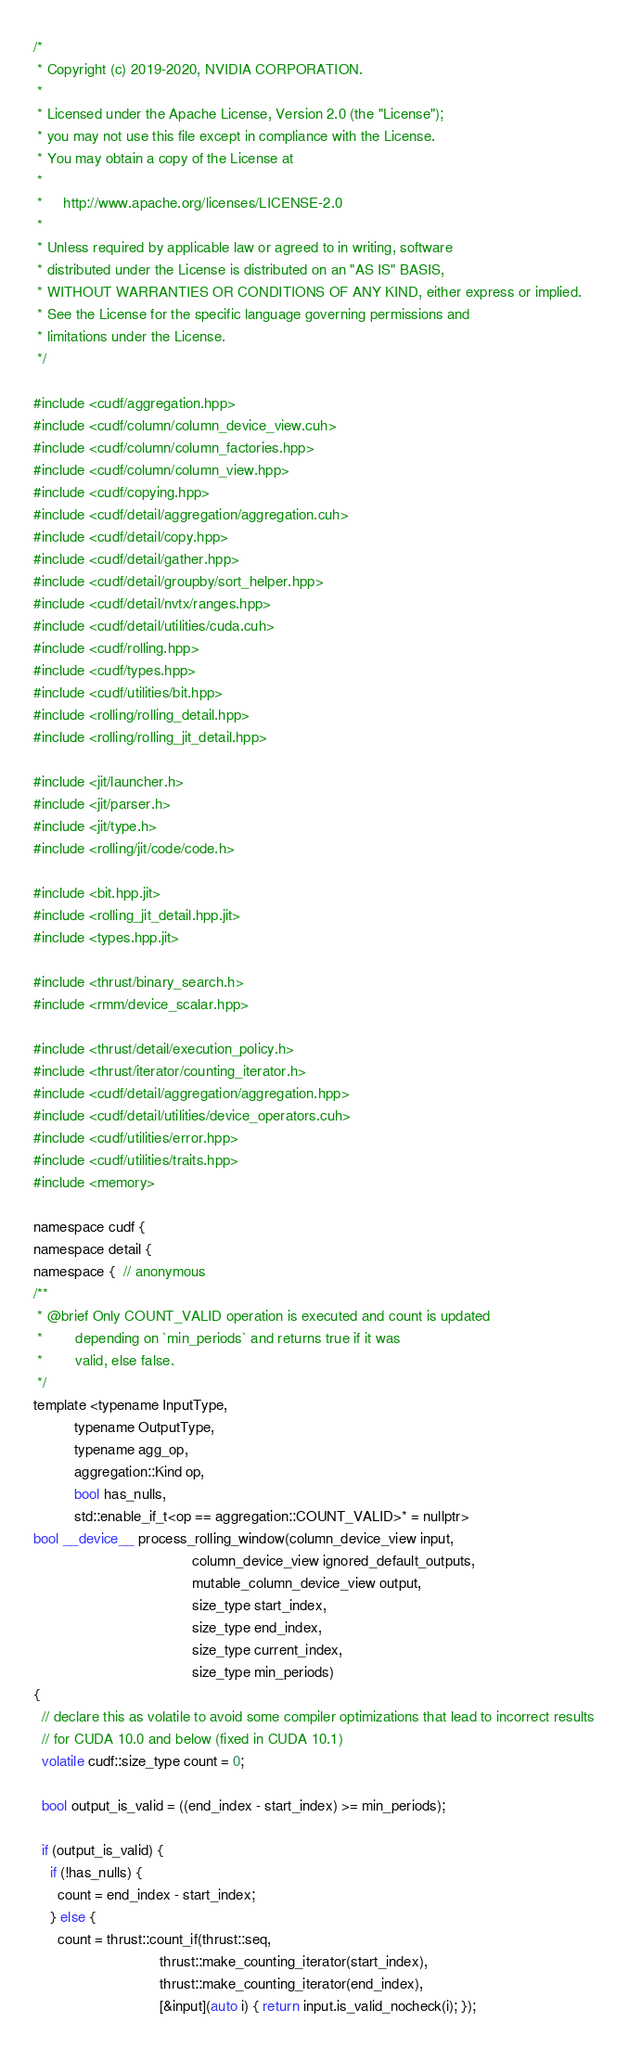<code> <loc_0><loc_0><loc_500><loc_500><_Cuda_>/*
 * Copyright (c) 2019-2020, NVIDIA CORPORATION.
 *
 * Licensed under the Apache License, Version 2.0 (the "License");
 * you may not use this file except in compliance with the License.
 * You may obtain a copy of the License at
 *
 *     http://www.apache.org/licenses/LICENSE-2.0
 *
 * Unless required by applicable law or agreed to in writing, software
 * distributed under the License is distributed on an "AS IS" BASIS,
 * WITHOUT WARRANTIES OR CONDITIONS OF ANY KIND, either express or implied.
 * See the License for the specific language governing permissions and
 * limitations under the License.
 */

#include <cudf/aggregation.hpp>
#include <cudf/column/column_device_view.cuh>
#include <cudf/column/column_factories.hpp>
#include <cudf/column/column_view.hpp>
#include <cudf/copying.hpp>
#include <cudf/detail/aggregation/aggregation.cuh>
#include <cudf/detail/copy.hpp>
#include <cudf/detail/gather.hpp>
#include <cudf/detail/groupby/sort_helper.hpp>
#include <cudf/detail/nvtx/ranges.hpp>
#include <cudf/detail/utilities/cuda.cuh>
#include <cudf/rolling.hpp>
#include <cudf/types.hpp>
#include <cudf/utilities/bit.hpp>
#include <rolling/rolling_detail.hpp>
#include <rolling/rolling_jit_detail.hpp>

#include <jit/launcher.h>
#include <jit/parser.h>
#include <jit/type.h>
#include <rolling/jit/code/code.h>

#include <bit.hpp.jit>
#include <rolling_jit_detail.hpp.jit>
#include <types.hpp.jit>

#include <thrust/binary_search.h>
#include <rmm/device_scalar.hpp>

#include <thrust/detail/execution_policy.h>
#include <thrust/iterator/counting_iterator.h>
#include <cudf/detail/aggregation/aggregation.hpp>
#include <cudf/detail/utilities/device_operators.cuh>
#include <cudf/utilities/error.hpp>
#include <cudf/utilities/traits.hpp>
#include <memory>

namespace cudf {
namespace detail {
namespace {  // anonymous
/**
 * @brief Only COUNT_VALID operation is executed and count is updated
 *        depending on `min_periods` and returns true if it was
 *        valid, else false.
 */
template <typename InputType,
          typename OutputType,
          typename agg_op,
          aggregation::Kind op,
          bool has_nulls,
          std::enable_if_t<op == aggregation::COUNT_VALID>* = nullptr>
bool __device__ process_rolling_window(column_device_view input,
                                       column_device_view ignored_default_outputs,
                                       mutable_column_device_view output,
                                       size_type start_index,
                                       size_type end_index,
                                       size_type current_index,
                                       size_type min_periods)
{
  // declare this as volatile to avoid some compiler optimizations that lead to incorrect results
  // for CUDA 10.0 and below (fixed in CUDA 10.1)
  volatile cudf::size_type count = 0;

  bool output_is_valid = ((end_index - start_index) >= min_periods);

  if (output_is_valid) {
    if (!has_nulls) {
      count = end_index - start_index;
    } else {
      count = thrust::count_if(thrust::seq,
                               thrust::make_counting_iterator(start_index),
                               thrust::make_counting_iterator(end_index),
                               [&input](auto i) { return input.is_valid_nocheck(i); });</code> 